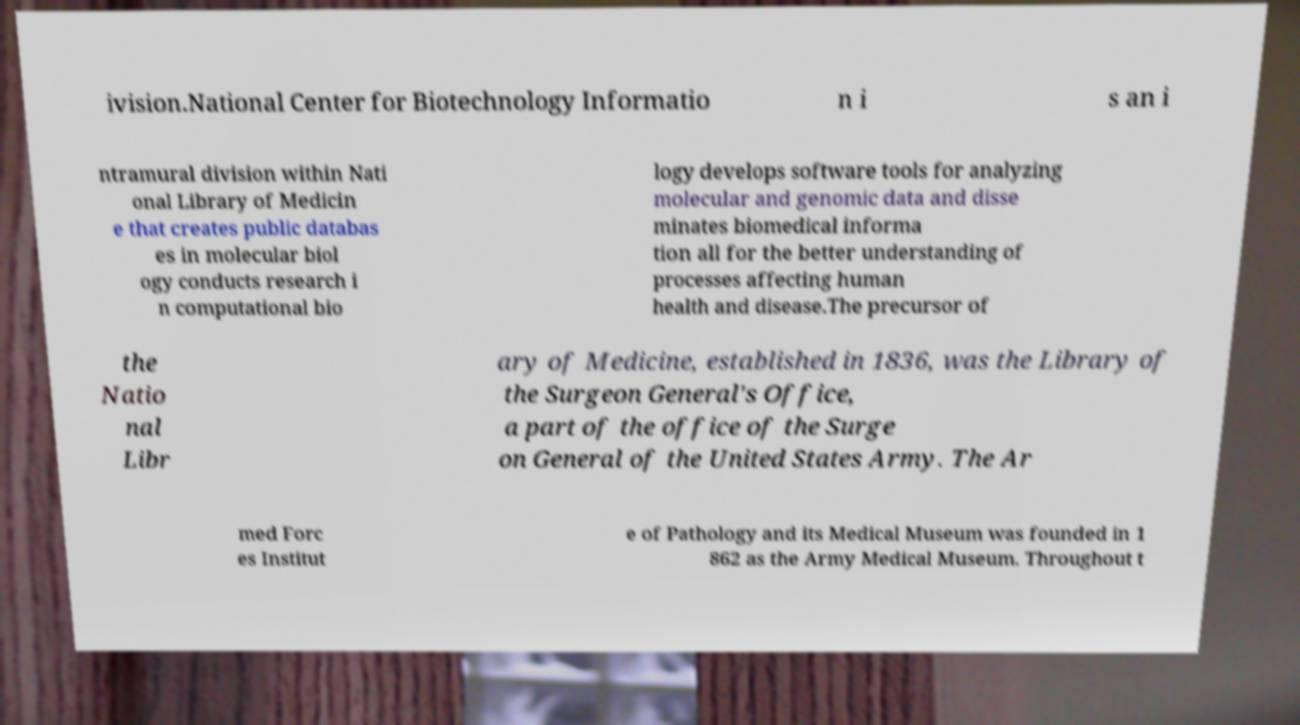Could you assist in decoding the text presented in this image and type it out clearly? ivision.National Center for Biotechnology Informatio n i s an i ntramural division within Nati onal Library of Medicin e that creates public databas es in molecular biol ogy conducts research i n computational bio logy develops software tools for analyzing molecular and genomic data and disse minates biomedical informa tion all for the better understanding of processes affecting human health and disease.The precursor of the Natio nal Libr ary of Medicine, established in 1836, was the Library of the Surgeon General's Office, a part of the office of the Surge on General of the United States Army. The Ar med Forc es Institut e of Pathology and its Medical Museum was founded in 1 862 as the Army Medical Museum. Throughout t 